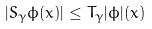<formula> <loc_0><loc_0><loc_500><loc_500>| S _ { \gamma } \phi ( x ) | \leq T _ { \gamma } | \phi | ( x )</formula> 